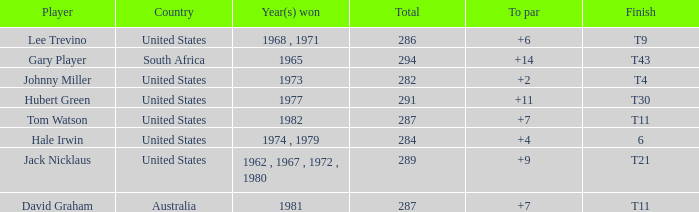WHAT IS THE TOTAL, OF A TO PAR FOR HUBERT GREEN, AND A TOTAL LARGER THAN 291? 0.0. 